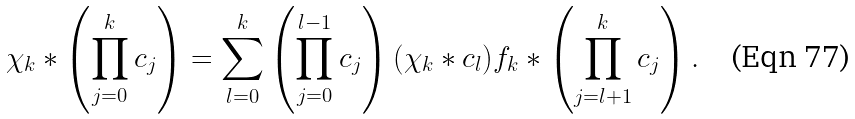Convert formula to latex. <formula><loc_0><loc_0><loc_500><loc_500>\chi _ { k } * \left ( \prod _ { j = 0 } ^ { k } c _ { j } \right ) = \sum _ { l = 0 } ^ { k } \left ( \prod _ { j = 0 } ^ { l - 1 } c _ { j } \right ) ( \chi _ { k } * c _ { l } ) f _ { k } * \left ( \prod _ { j = l + 1 } ^ { k } c _ { j } \right ) .</formula> 